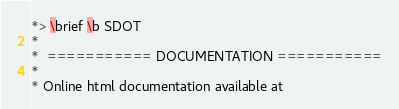Convert code to text. <code><loc_0><loc_0><loc_500><loc_500><_FORTRAN_>*> \brief \b SDOT
*
*  =========== DOCUMENTATION ===========
*
* Online html documentation available at</code> 